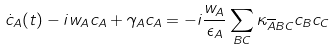Convert formula to latex. <formula><loc_0><loc_0><loc_500><loc_500>\dot { c } _ { A } ( t ) - i w _ { A } c _ { A } + \gamma _ { A } c _ { A } = - i \frac { w _ { A } } { \epsilon _ { A } } \sum _ { B C } \kappa _ { \overline { A } B C } c _ { B } c _ { C }</formula> 